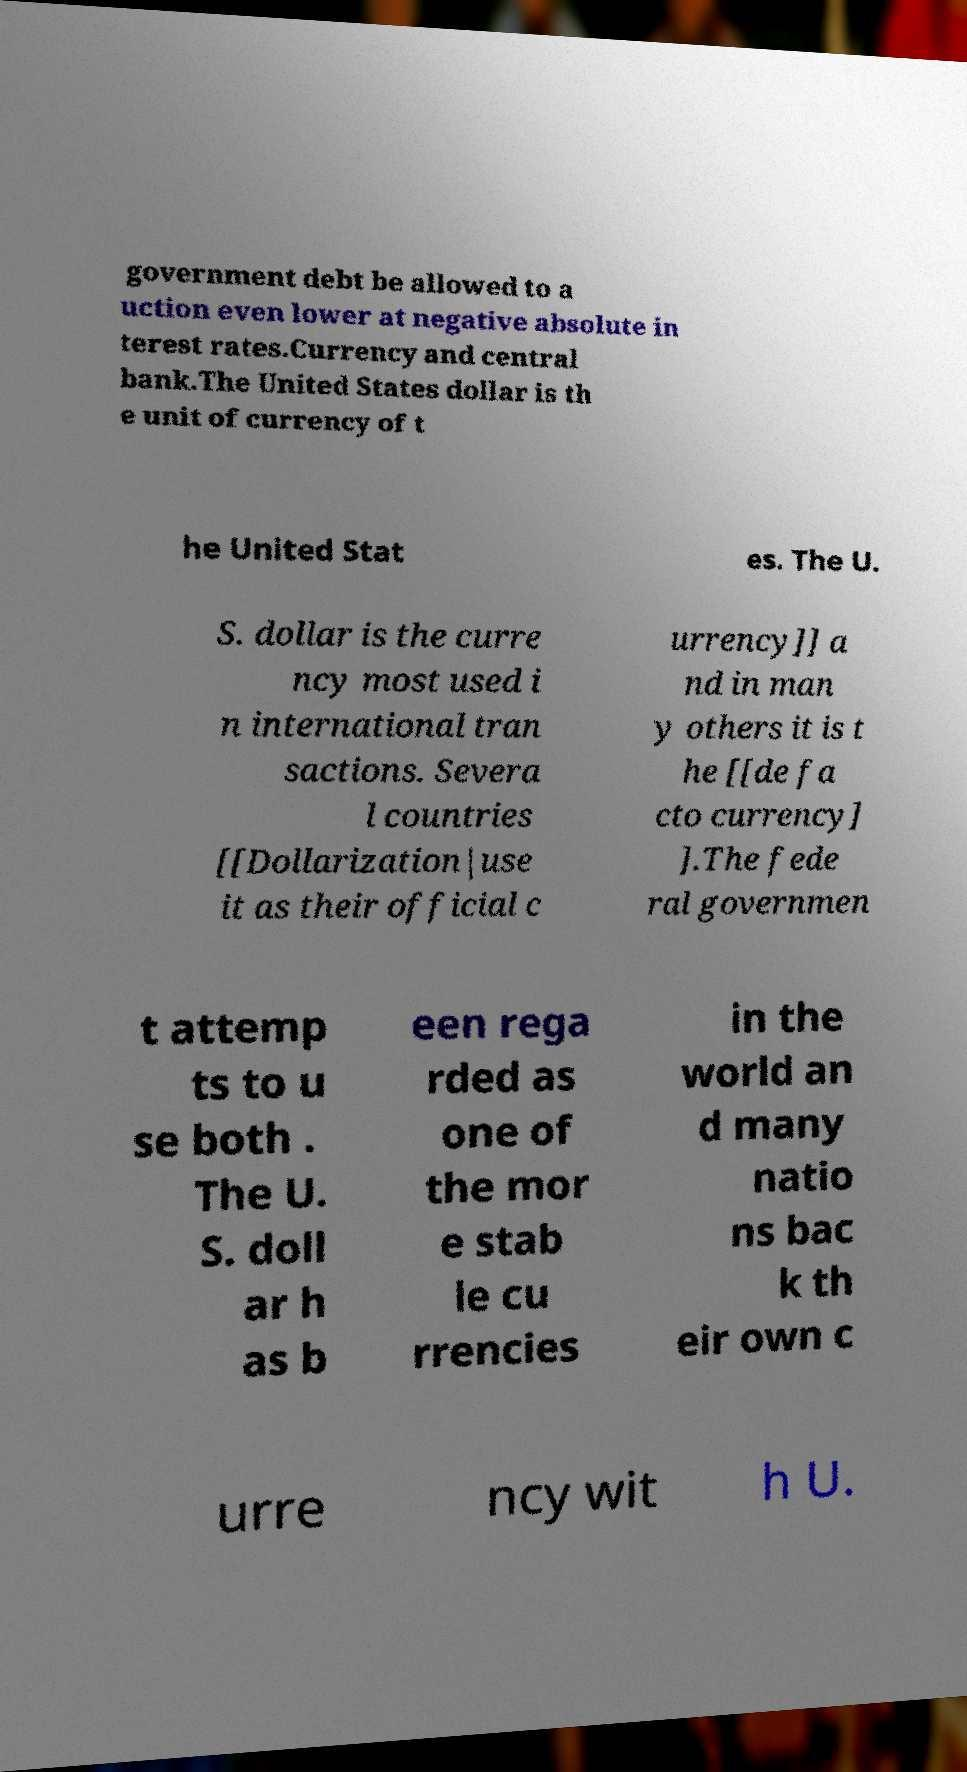Please read and relay the text visible in this image. What does it say? government debt be allowed to a uction even lower at negative absolute in terest rates.Currency and central bank.The United States dollar is th e unit of currency of t he United Stat es. The U. S. dollar is the curre ncy most used i n international tran sactions. Severa l countries [[Dollarization|use it as their official c urrency]] a nd in man y others it is t he [[de fa cto currency] ].The fede ral governmen t attemp ts to u se both . The U. S. doll ar h as b een rega rded as one of the mor e stab le cu rrencies in the world an d many natio ns bac k th eir own c urre ncy wit h U. 